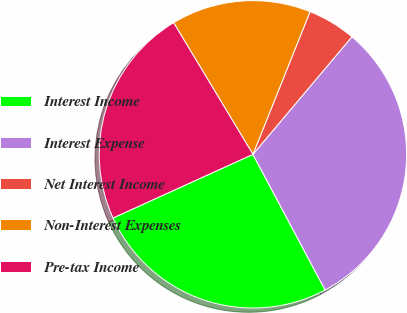Convert chart. <chart><loc_0><loc_0><loc_500><loc_500><pie_chart><fcel>Interest Income<fcel>Interest Expense<fcel>Net Interest Income<fcel>Non-Interest Expenses<fcel>Pre-tax Income<nl><fcel>25.99%<fcel>31.07%<fcel>5.08%<fcel>14.69%<fcel>23.16%<nl></chart> 